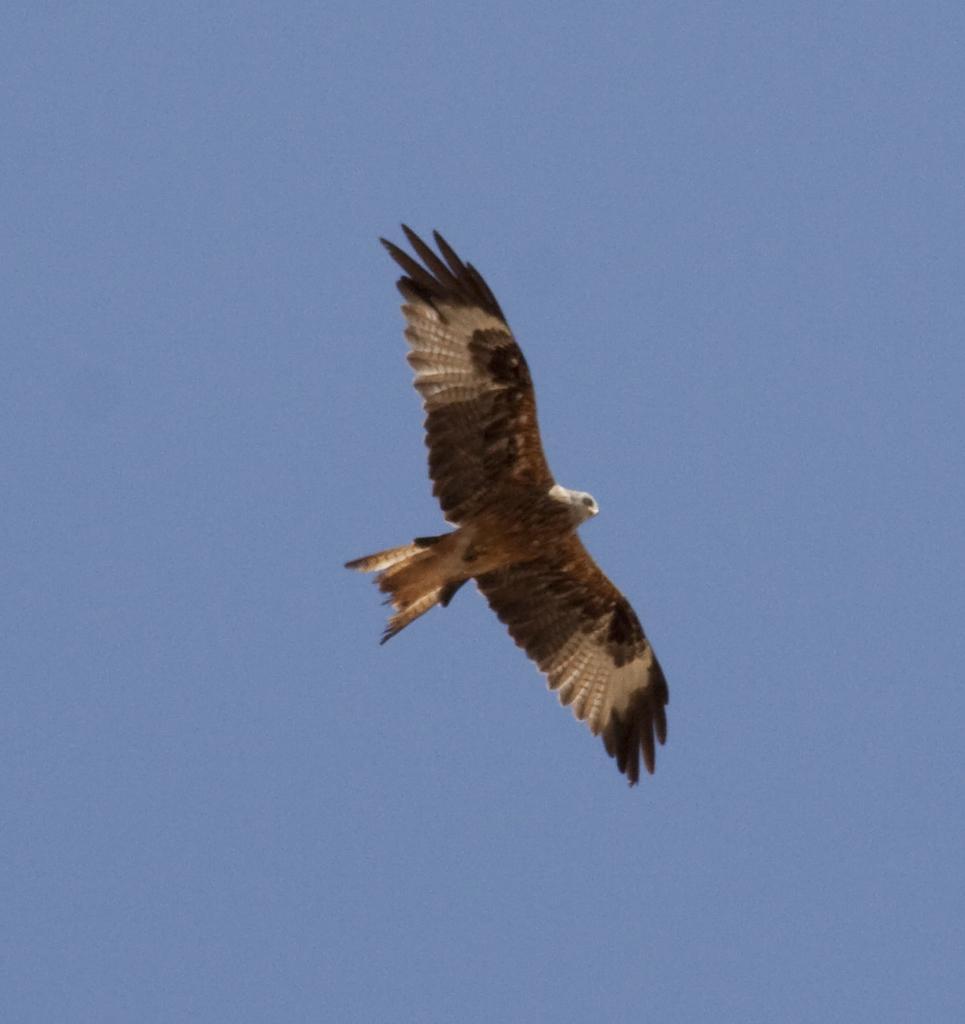Can you describe this image briefly? In this image we can see a bird in the sky. 